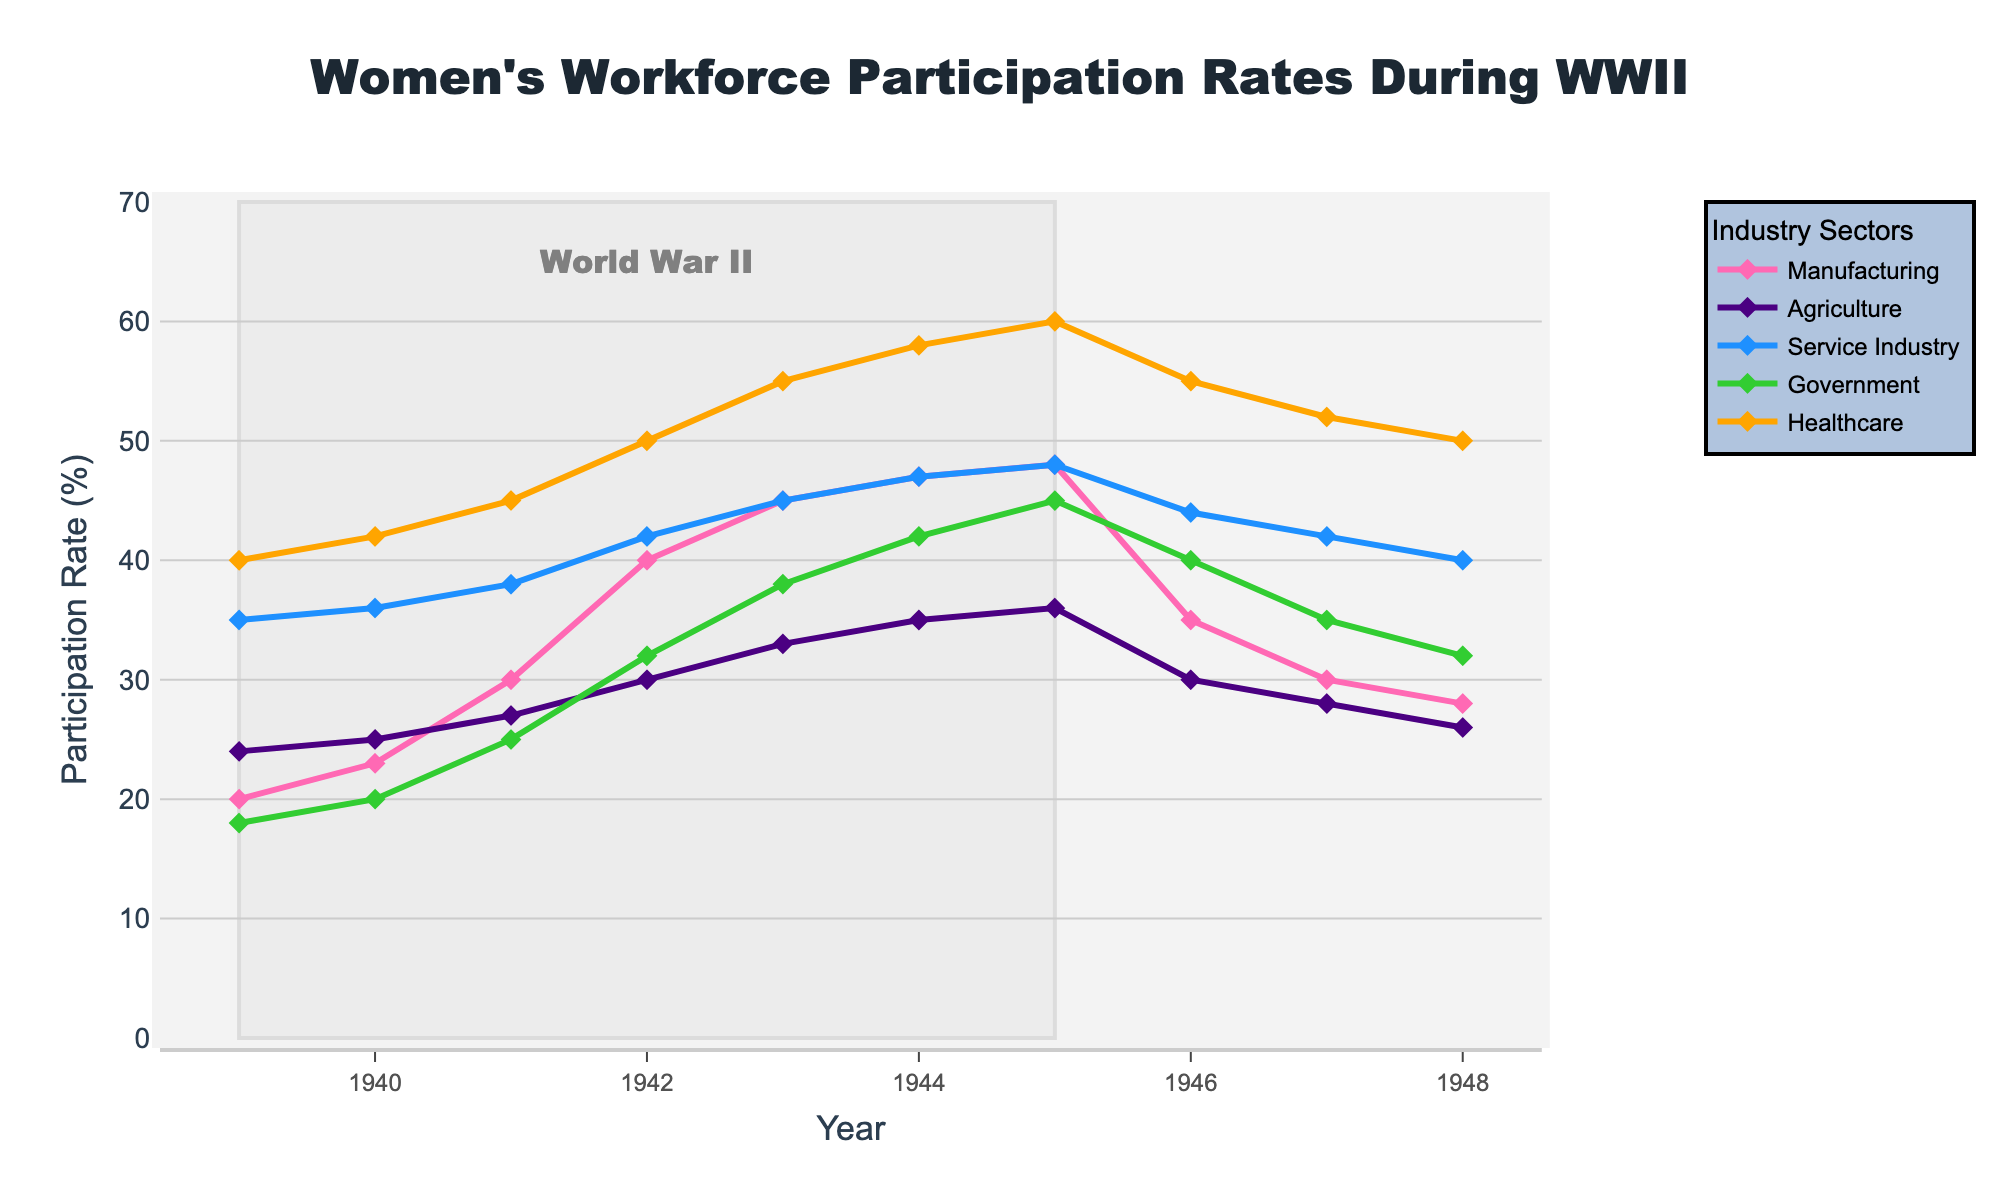What's the highest women's workforce participation rate in the manufacturing industry during WWII? The highest participation rate in the manufacturing industry during WWII can be observed from the highest point on the manufacturing line within the shaded area representing WWII. The highest rate is at 48% in 1945.
Answer: 48% Which year saw the highest participation rate in the healthcare sector during WWII? The healthcare sector is represented by the line in a specific color. By observing this line within the shaded WWII area, the highest point is in 1945 at 60%.
Answer: 1945 Between which years did the service industry see the largest increase in women's workforce participation rates during WWII? By comparing the service industry line within the shaded WWII area, the largest vertical rise is from 1941 to 1942, where the rate went from 38% to 42%.
Answer: 1941 to 1942 How did the women's workforce participation rate in the government sector change from 1939 to 1945? To determine the change, find the difference between the participation rates in 1945 and 1939 for the government sector line. The rate increased from 18% in 1939 to 45% in 1945.
Answer: Increased by 27% Which industry saw the least fluctuation in women's workforce participation rates from 1939 to 1948? By observing all the lines from 1939 to 1948, the agriculture sector's line shows the least deviation, fluctuating between 24% and 36%.
Answer: Agriculture What is the average women's workforce participation rate in the manufacturing industry during WWII? To find the average, sum the manufacturing participation rates from 1939 to 1945 and divide by the number of years. (20 + 23 + 30 + 40 + 45 + 47 + 48) / 7 = 36.14%.
Answer: 36.14% Did any industry exceed a 50% women's workforce participation rate during the period shown? From the lines in the chart, only the healthcare industry line exceeds 50%, reaching up to 60% during the period.
Answer: Yes What is the difference in women's workforce participation rates in the service industry between the start and end of WWII? Subtract the 1939 rate from the 1945 rate in the service industry line. The participation rate went from 35% in 1939 to 48% in 1945. The difference is 13%.
Answer: 13% How does the manufacturing participation rate in 1943 compare to the healthcare participation rate in the same year? Compare the values for both lines in 1943. The manufacturing rate is at 45%, while the healthcare rate is at 55%. The healthcare rate is higher by 10%.
Answer: Healthcare is higher by 10% 